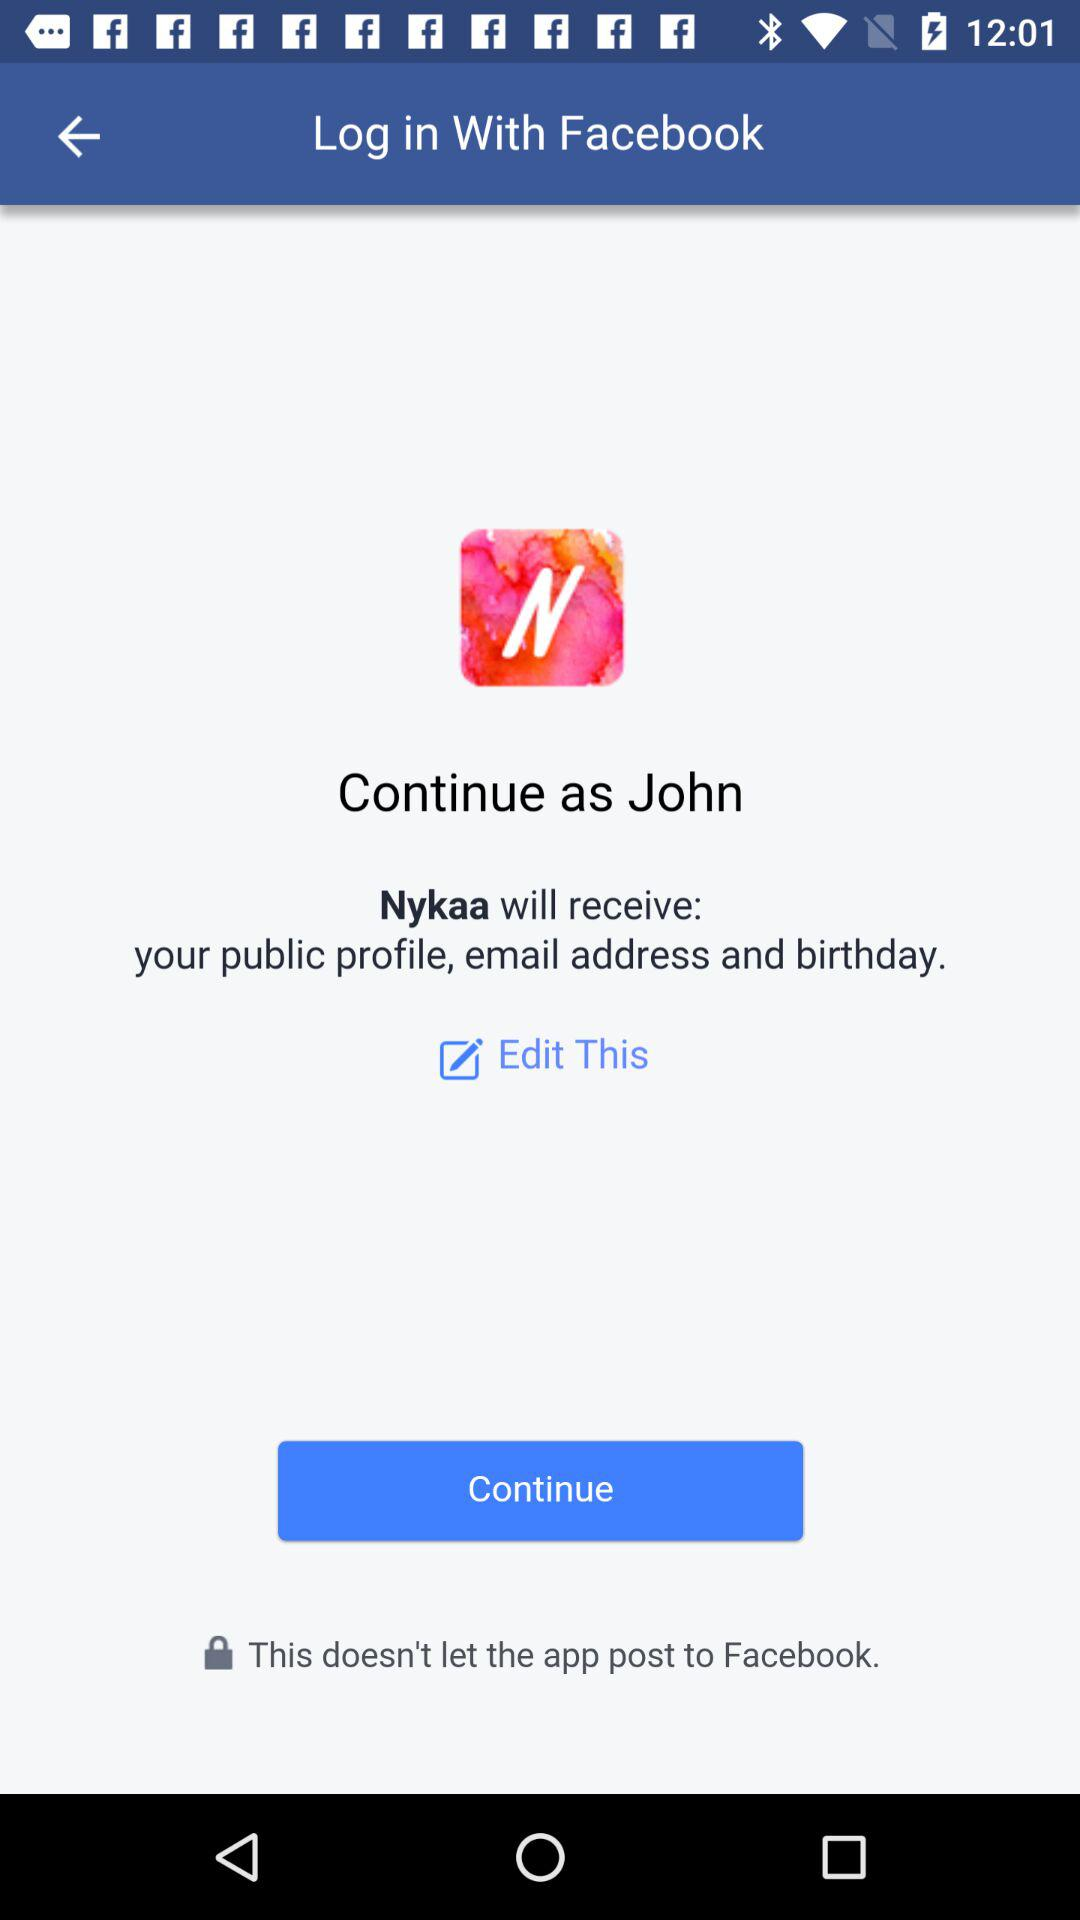What application is asking for permission? The application asking for permission is "Nykaa". 